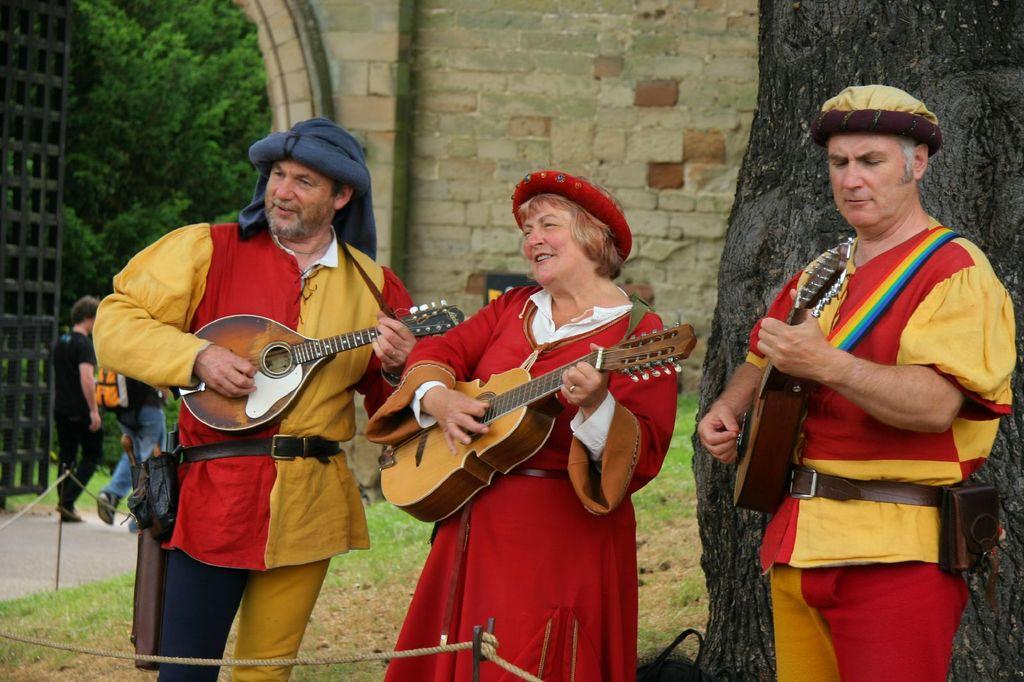How many people are playing guitars in the image? There are three persons in the image, and they are playing guitars. What is the background of the image like? The background includes grass, a wall, and trees. Can you describe the activity of the two persons in the image who are not playing guitars? There are two persons walking on a road in the image. What type of wool is being used to make the guitars in the image? There is no wool mentioned or visible in the image; the guitars are made of different materials, such as wood. 